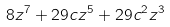<formula> <loc_0><loc_0><loc_500><loc_500>8 z ^ { 7 } + 2 9 c z ^ { 5 } + 2 9 c ^ { 2 } z ^ { 3 }</formula> 